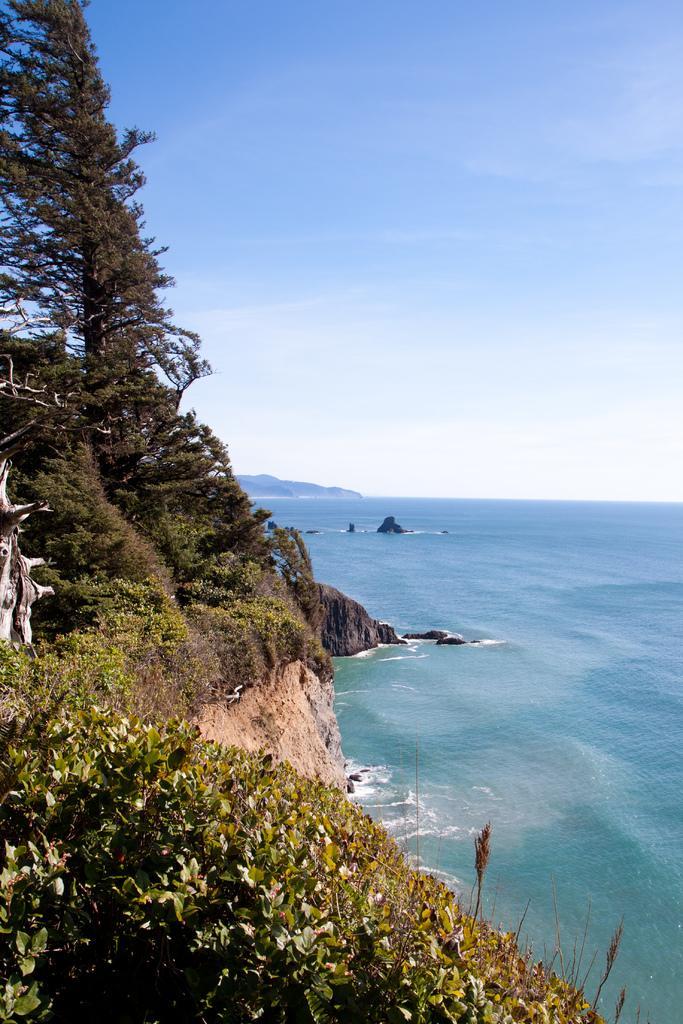How would you summarize this image in a sentence or two? In this image in front there are plants. On the right side of the image there is water. There are rocks. In the background of the image there are mountains and sky. 